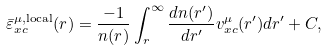Convert formula to latex. <formula><loc_0><loc_0><loc_500><loc_500>\bar { \varepsilon } _ { x c } ^ { \mu , \text {local} } ( r ) = \frac { - 1 } { n ( r ) } \int _ { r } ^ { \infty } \frac { d n ( r ^ { \prime } ) } { d r ^ { \prime } } v _ { x c } ^ { \mu } ( r ^ { \prime } ) d r ^ { \prime } + C ,</formula> 